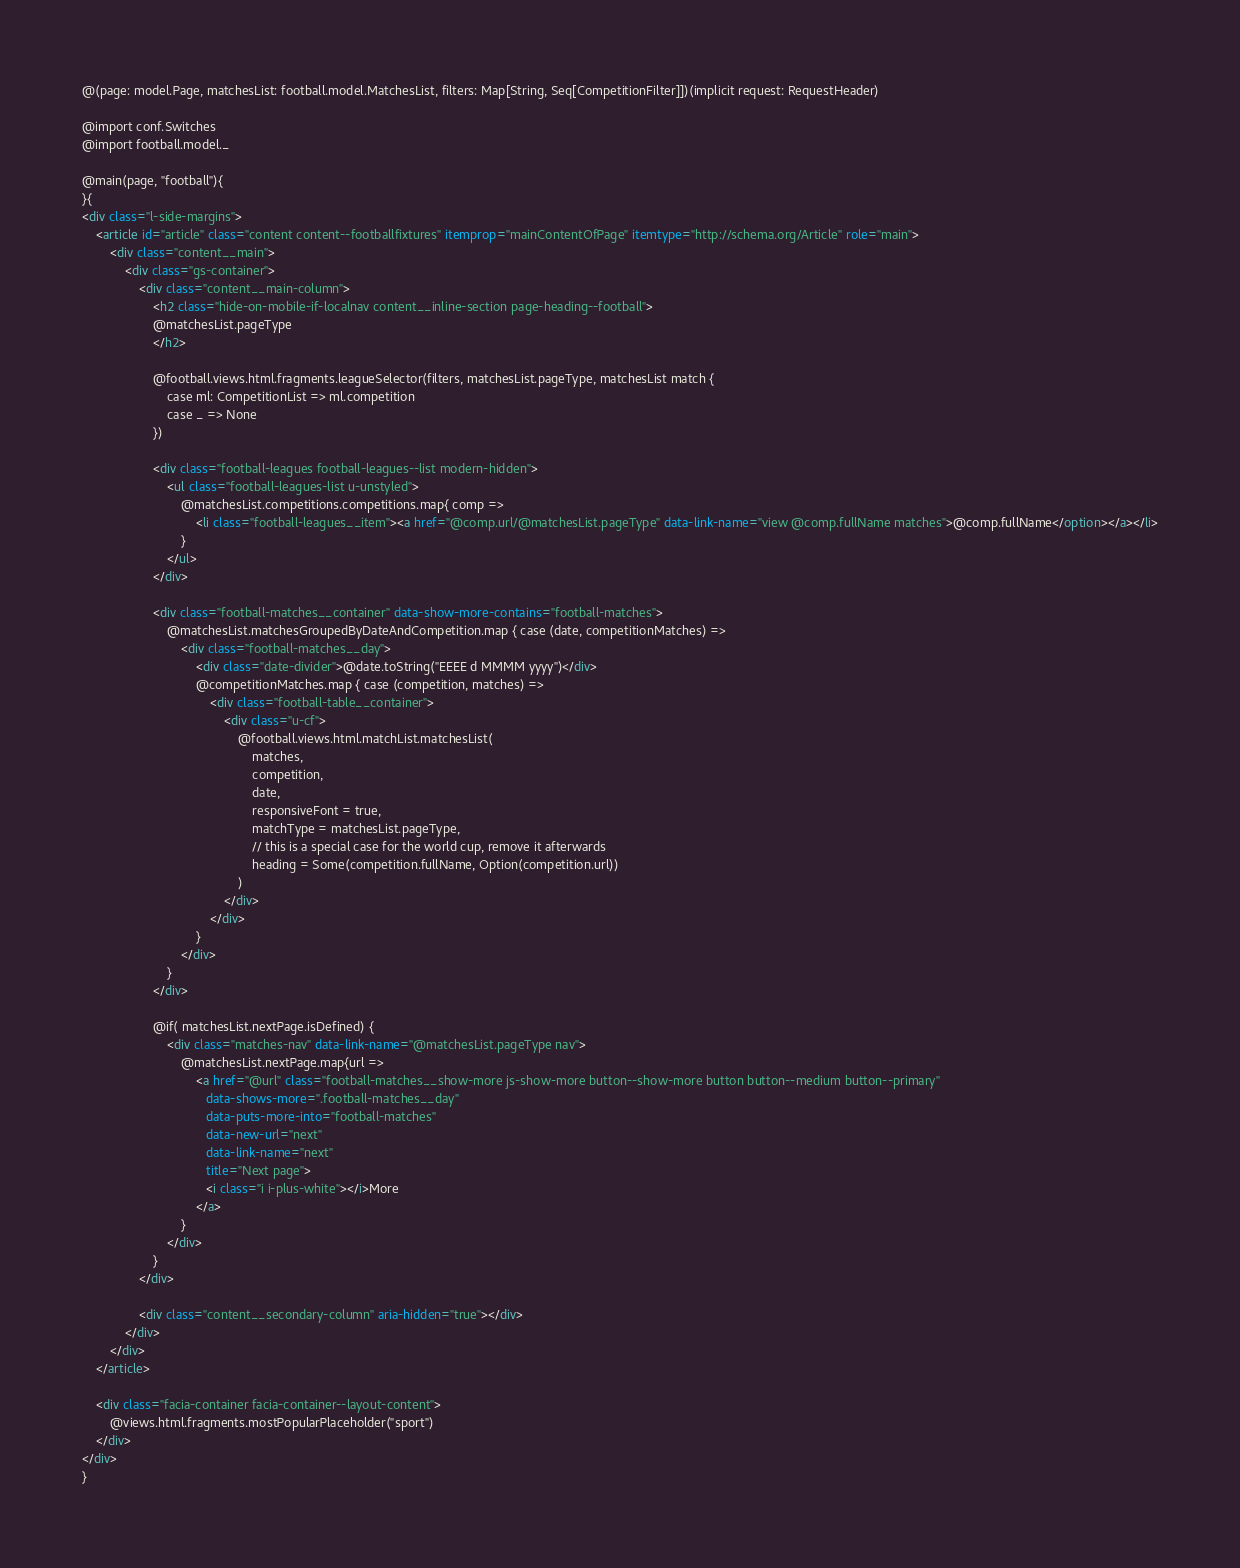<code> <loc_0><loc_0><loc_500><loc_500><_HTML_>@(page: model.Page, matchesList: football.model.MatchesList, filters: Map[String, Seq[CompetitionFilter]])(implicit request: RequestHeader)

@import conf.Switches
@import football.model._

@main(page, "football"){
}{
<div class="l-side-margins">
    <article id="article" class="content content--footballfixtures" itemprop="mainContentOfPage" itemtype="http://schema.org/Article" role="main">
        <div class="content__main">
            <div class="gs-container">
                <div class="content__main-column">
                    <h2 class="hide-on-mobile-if-localnav content__inline-section page-heading--football">
                    @matchesList.pageType
                    </h2>

                    @football.views.html.fragments.leagueSelector(filters, matchesList.pageType, matchesList match {
                        case ml: CompetitionList => ml.competition
                        case _ => None
                    })

                    <div class="football-leagues football-leagues--list modern-hidden">
                        <ul class="football-leagues-list u-unstyled">
                            @matchesList.competitions.competitions.map{ comp =>
                                <li class="football-leagues__item"><a href="@comp.url/@matchesList.pageType" data-link-name="view @comp.fullName matches">@comp.fullName</option></a></li>
                            }
                        </ul>
                    </div>

                    <div class="football-matches__container" data-show-more-contains="football-matches">
                        @matchesList.matchesGroupedByDateAndCompetition.map { case (date, competitionMatches) =>
                            <div class="football-matches__day">
                                <div class="date-divider">@date.toString("EEEE d MMMM yyyy")</div>
                                @competitionMatches.map { case (competition, matches) =>
                                    <div class="football-table__container">
                                        <div class="u-cf">
                                            @football.views.html.matchList.matchesList(
                                                matches,
                                                competition,
                                                date,
                                                responsiveFont = true,
                                                matchType = matchesList.pageType,
                                                // this is a special case for the world cup, remove it afterwards
                                                heading = Some(competition.fullName, Option(competition.url))
                                            )
                                        </div>
                                    </div>
                                }
                            </div>
                        }
                    </div>

                    @if( matchesList.nextPage.isDefined) {
                        <div class="matches-nav" data-link-name="@matchesList.pageType nav">
                            @matchesList.nextPage.map{url =>
                                <a href="@url" class="football-matches__show-more js-show-more button--show-more button button--medium button--primary"
                                   data-shows-more=".football-matches__day"
                                   data-puts-more-into="football-matches"
                                   data-new-url="next"
                                   data-link-name="next"
                                   title="Next page">
                                   <i class="i i-plus-white"></i>More
                                </a>
                            }
                        </div>
                    }
                </div>

                <div class="content__secondary-column" aria-hidden="true"></div>
            </div>
        </div>
    </article>

    <div class="facia-container facia-container--layout-content">
        @views.html.fragments.mostPopularPlaceholder("sport")
    </div>
</div>
}
</code> 